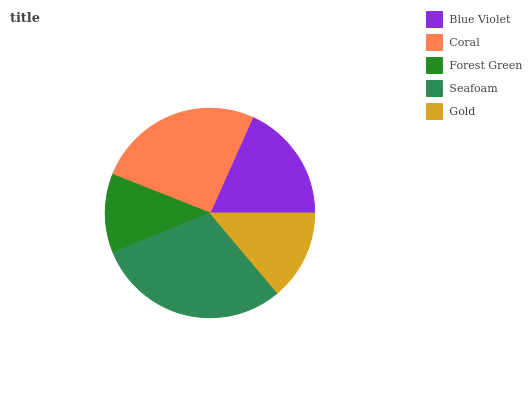Is Forest Green the minimum?
Answer yes or no. Yes. Is Seafoam the maximum?
Answer yes or no. Yes. Is Coral the minimum?
Answer yes or no. No. Is Coral the maximum?
Answer yes or no. No. Is Coral greater than Blue Violet?
Answer yes or no. Yes. Is Blue Violet less than Coral?
Answer yes or no. Yes. Is Blue Violet greater than Coral?
Answer yes or no. No. Is Coral less than Blue Violet?
Answer yes or no. No. Is Blue Violet the high median?
Answer yes or no. Yes. Is Blue Violet the low median?
Answer yes or no. Yes. Is Seafoam the high median?
Answer yes or no. No. Is Forest Green the low median?
Answer yes or no. No. 